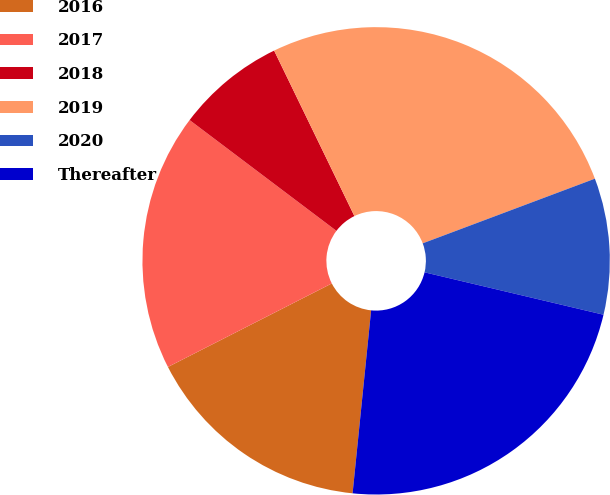<chart> <loc_0><loc_0><loc_500><loc_500><pie_chart><fcel>2016<fcel>2017<fcel>2018<fcel>2019<fcel>2020<fcel>Thereafter<nl><fcel>15.89%<fcel>17.79%<fcel>7.52%<fcel>26.47%<fcel>9.42%<fcel>22.9%<nl></chart> 